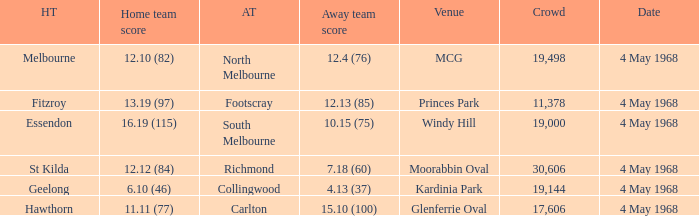Could you parse the entire table as a dict? {'header': ['HT', 'Home team score', 'AT', 'Away team score', 'Venue', 'Crowd', 'Date'], 'rows': [['Melbourne', '12.10 (82)', 'North Melbourne', '12.4 (76)', 'MCG', '19,498', '4 May 1968'], ['Fitzroy', '13.19 (97)', 'Footscray', '12.13 (85)', 'Princes Park', '11,378', '4 May 1968'], ['Essendon', '16.19 (115)', 'South Melbourne', '10.15 (75)', 'Windy Hill', '19,000', '4 May 1968'], ['St Kilda', '12.12 (84)', 'Richmond', '7.18 (60)', 'Moorabbin Oval', '30,606', '4 May 1968'], ['Geelong', '6.10 (46)', 'Collingwood', '4.13 (37)', 'Kardinia Park', '19,144', '4 May 1968'], ['Hawthorn', '11.11 (77)', 'Carlton', '15.10 (100)', 'Glenferrie Oval', '17,606', '4 May 1968']]} What team played at Moorabbin Oval to a crowd of 19,144? St Kilda. 